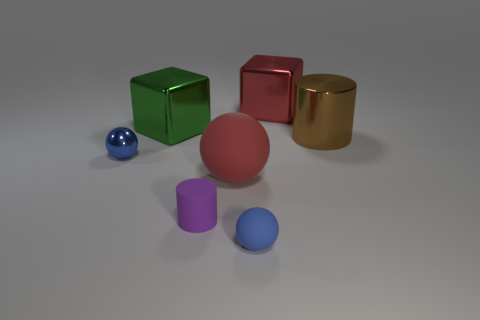Can you tell me more about the blue sphere's material? The blue sphere seems to have a smooth, shiny surface, indicative of a polished glass or plastic material. Such materials are chosen for their clarity and reflective qualities. 